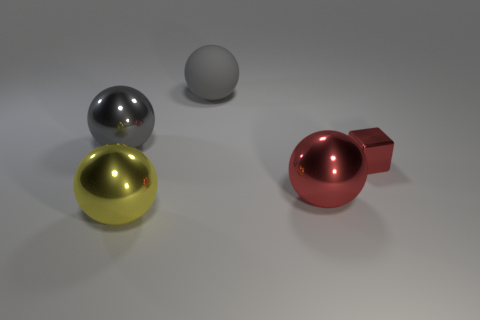The metal ball that is the same color as the metallic block is what size?
Your response must be concise. Large. What is the color of the matte thing that is the same size as the yellow metallic object?
Make the answer very short. Gray. The large metallic object on the right side of the shiny sphere in front of the red metallic thing that is left of the red cube is what shape?
Your answer should be compact. Sphere. How many balls are to the left of the ball that is right of the gray rubber sphere?
Make the answer very short. 3. Does the large shiny thing to the right of the large yellow ball have the same shape as the big gray thing that is on the right side of the gray metal sphere?
Your response must be concise. Yes. What number of shiny things are in front of the block?
Ensure brevity in your answer.  2. Are the gray ball right of the large gray metal object and the block made of the same material?
Provide a short and direct response. No. The large gray matte object is what shape?
Your response must be concise. Sphere. What number of things are gray things or tiny shiny balls?
Provide a succinct answer. 2. There is a shiny sphere behind the small red metallic cube; is it the same color as the large thing right of the big rubber ball?
Offer a very short reply. No. 